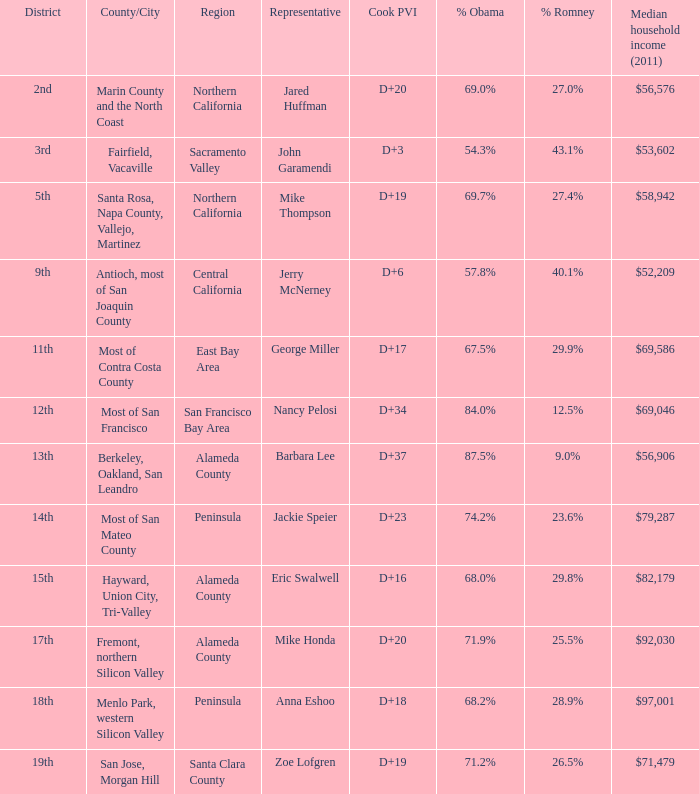What is the location that has the 12th district? Most of San Francisco. 